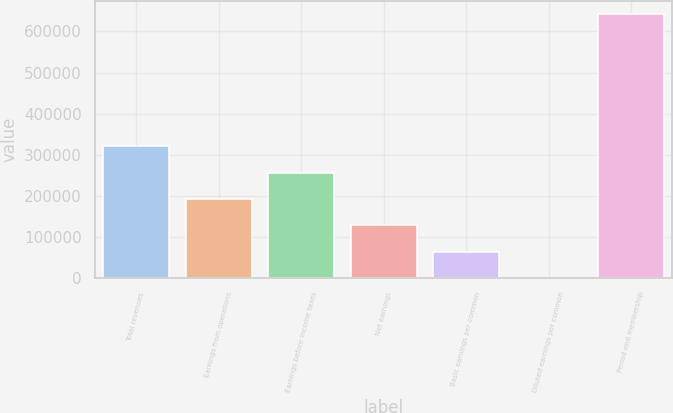<chart> <loc_0><loc_0><loc_500><loc_500><bar_chart><fcel>Total revenues<fcel>Earnings from operations<fcel>Earnings before income taxes<fcel>Net earnings<fcel>Basic earnings per common<fcel>Diluted earnings per common<fcel>Period end membership<nl><fcel>320800<fcel>192480<fcel>256640<fcel>128320<fcel>64160.2<fcel>0.26<fcel>641600<nl></chart> 